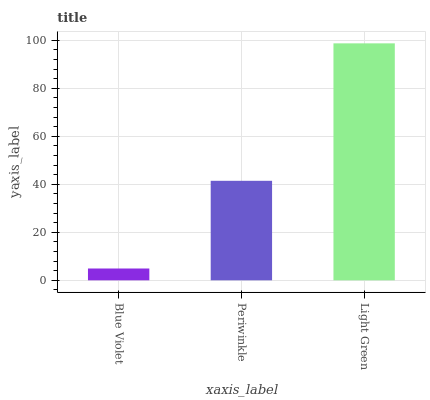Is Periwinkle the minimum?
Answer yes or no. No. Is Periwinkle the maximum?
Answer yes or no. No. Is Periwinkle greater than Blue Violet?
Answer yes or no. Yes. Is Blue Violet less than Periwinkle?
Answer yes or no. Yes. Is Blue Violet greater than Periwinkle?
Answer yes or no. No. Is Periwinkle less than Blue Violet?
Answer yes or no. No. Is Periwinkle the high median?
Answer yes or no. Yes. Is Periwinkle the low median?
Answer yes or no. Yes. Is Light Green the high median?
Answer yes or no. No. Is Blue Violet the low median?
Answer yes or no. No. 